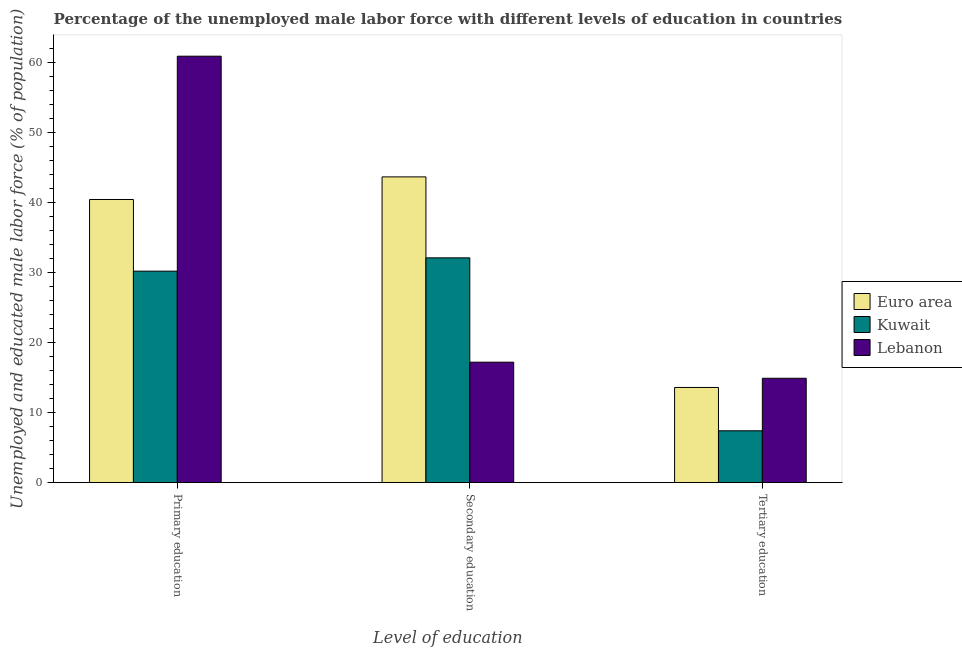How many different coloured bars are there?
Make the answer very short. 3. How many groups of bars are there?
Your answer should be very brief. 3. Are the number of bars on each tick of the X-axis equal?
Provide a short and direct response. Yes. How many bars are there on the 2nd tick from the left?
Provide a succinct answer. 3. What is the label of the 2nd group of bars from the left?
Your response must be concise. Secondary education. What is the percentage of male labor force who received secondary education in Euro area?
Provide a succinct answer. 43.66. Across all countries, what is the maximum percentage of male labor force who received tertiary education?
Provide a short and direct response. 14.9. Across all countries, what is the minimum percentage of male labor force who received primary education?
Offer a terse response. 30.2. In which country was the percentage of male labor force who received primary education maximum?
Ensure brevity in your answer.  Lebanon. In which country was the percentage of male labor force who received secondary education minimum?
Your answer should be very brief. Lebanon. What is the total percentage of male labor force who received secondary education in the graph?
Provide a succinct answer. 92.96. What is the difference between the percentage of male labor force who received tertiary education in Euro area and that in Kuwait?
Offer a terse response. 6.19. What is the difference between the percentage of male labor force who received tertiary education in Euro area and the percentage of male labor force who received primary education in Lebanon?
Provide a succinct answer. -47.31. What is the average percentage of male labor force who received tertiary education per country?
Make the answer very short. 11.96. What is the difference between the percentage of male labor force who received secondary education and percentage of male labor force who received primary education in Lebanon?
Your answer should be compact. -43.7. In how many countries, is the percentage of male labor force who received primary education greater than 26 %?
Offer a terse response. 3. What is the ratio of the percentage of male labor force who received primary education in Kuwait to that in Lebanon?
Provide a short and direct response. 0.5. Is the percentage of male labor force who received primary education in Lebanon less than that in Euro area?
Offer a very short reply. No. What is the difference between the highest and the second highest percentage of male labor force who received primary education?
Give a very brief answer. 20.47. What is the difference between the highest and the lowest percentage of male labor force who received tertiary education?
Provide a succinct answer. 7.5. In how many countries, is the percentage of male labor force who received primary education greater than the average percentage of male labor force who received primary education taken over all countries?
Offer a very short reply. 1. What does the 3rd bar from the left in Tertiary education represents?
Offer a very short reply. Lebanon. What does the 2nd bar from the right in Primary education represents?
Ensure brevity in your answer.  Kuwait. How many bars are there?
Keep it short and to the point. 9. Are all the bars in the graph horizontal?
Provide a short and direct response. No. How many countries are there in the graph?
Your response must be concise. 3. What is the difference between two consecutive major ticks on the Y-axis?
Provide a short and direct response. 10. Are the values on the major ticks of Y-axis written in scientific E-notation?
Your response must be concise. No. Where does the legend appear in the graph?
Give a very brief answer. Center right. What is the title of the graph?
Your answer should be compact. Percentage of the unemployed male labor force with different levels of education in countries. Does "Egypt, Arab Rep." appear as one of the legend labels in the graph?
Keep it short and to the point. No. What is the label or title of the X-axis?
Provide a short and direct response. Level of education. What is the label or title of the Y-axis?
Your answer should be compact. Unemployed and educated male labor force (% of population). What is the Unemployed and educated male labor force (% of population) in Euro area in Primary education?
Offer a very short reply. 40.43. What is the Unemployed and educated male labor force (% of population) of Kuwait in Primary education?
Ensure brevity in your answer.  30.2. What is the Unemployed and educated male labor force (% of population) of Lebanon in Primary education?
Your response must be concise. 60.9. What is the Unemployed and educated male labor force (% of population) in Euro area in Secondary education?
Make the answer very short. 43.66. What is the Unemployed and educated male labor force (% of population) of Kuwait in Secondary education?
Ensure brevity in your answer.  32.1. What is the Unemployed and educated male labor force (% of population) of Lebanon in Secondary education?
Provide a short and direct response. 17.2. What is the Unemployed and educated male labor force (% of population) of Euro area in Tertiary education?
Your response must be concise. 13.59. What is the Unemployed and educated male labor force (% of population) in Kuwait in Tertiary education?
Offer a very short reply. 7.4. What is the Unemployed and educated male labor force (% of population) in Lebanon in Tertiary education?
Offer a terse response. 14.9. Across all Level of education, what is the maximum Unemployed and educated male labor force (% of population) in Euro area?
Your answer should be very brief. 43.66. Across all Level of education, what is the maximum Unemployed and educated male labor force (% of population) in Kuwait?
Offer a very short reply. 32.1. Across all Level of education, what is the maximum Unemployed and educated male labor force (% of population) in Lebanon?
Keep it short and to the point. 60.9. Across all Level of education, what is the minimum Unemployed and educated male labor force (% of population) of Euro area?
Ensure brevity in your answer.  13.59. Across all Level of education, what is the minimum Unemployed and educated male labor force (% of population) in Kuwait?
Offer a terse response. 7.4. Across all Level of education, what is the minimum Unemployed and educated male labor force (% of population) in Lebanon?
Ensure brevity in your answer.  14.9. What is the total Unemployed and educated male labor force (% of population) of Euro area in the graph?
Keep it short and to the point. 97.69. What is the total Unemployed and educated male labor force (% of population) in Kuwait in the graph?
Give a very brief answer. 69.7. What is the total Unemployed and educated male labor force (% of population) in Lebanon in the graph?
Give a very brief answer. 93. What is the difference between the Unemployed and educated male labor force (% of population) in Euro area in Primary education and that in Secondary education?
Offer a terse response. -3.23. What is the difference between the Unemployed and educated male labor force (% of population) in Lebanon in Primary education and that in Secondary education?
Provide a short and direct response. 43.7. What is the difference between the Unemployed and educated male labor force (% of population) of Euro area in Primary education and that in Tertiary education?
Ensure brevity in your answer.  26.84. What is the difference between the Unemployed and educated male labor force (% of population) in Kuwait in Primary education and that in Tertiary education?
Give a very brief answer. 22.8. What is the difference between the Unemployed and educated male labor force (% of population) in Lebanon in Primary education and that in Tertiary education?
Your answer should be compact. 46. What is the difference between the Unemployed and educated male labor force (% of population) of Euro area in Secondary education and that in Tertiary education?
Your answer should be compact. 30.07. What is the difference between the Unemployed and educated male labor force (% of population) of Kuwait in Secondary education and that in Tertiary education?
Your response must be concise. 24.7. What is the difference between the Unemployed and educated male labor force (% of population) in Euro area in Primary education and the Unemployed and educated male labor force (% of population) in Kuwait in Secondary education?
Provide a short and direct response. 8.33. What is the difference between the Unemployed and educated male labor force (% of population) in Euro area in Primary education and the Unemployed and educated male labor force (% of population) in Lebanon in Secondary education?
Keep it short and to the point. 23.23. What is the difference between the Unemployed and educated male labor force (% of population) of Euro area in Primary education and the Unemployed and educated male labor force (% of population) of Kuwait in Tertiary education?
Make the answer very short. 33.03. What is the difference between the Unemployed and educated male labor force (% of population) in Euro area in Primary education and the Unemployed and educated male labor force (% of population) in Lebanon in Tertiary education?
Make the answer very short. 25.53. What is the difference between the Unemployed and educated male labor force (% of population) in Euro area in Secondary education and the Unemployed and educated male labor force (% of population) in Kuwait in Tertiary education?
Offer a terse response. 36.26. What is the difference between the Unemployed and educated male labor force (% of population) of Euro area in Secondary education and the Unemployed and educated male labor force (% of population) of Lebanon in Tertiary education?
Offer a terse response. 28.76. What is the difference between the Unemployed and educated male labor force (% of population) in Kuwait in Secondary education and the Unemployed and educated male labor force (% of population) in Lebanon in Tertiary education?
Your answer should be very brief. 17.2. What is the average Unemployed and educated male labor force (% of population) in Euro area per Level of education?
Offer a very short reply. 32.56. What is the average Unemployed and educated male labor force (% of population) of Kuwait per Level of education?
Provide a short and direct response. 23.23. What is the difference between the Unemployed and educated male labor force (% of population) in Euro area and Unemployed and educated male labor force (% of population) in Kuwait in Primary education?
Provide a short and direct response. 10.23. What is the difference between the Unemployed and educated male labor force (% of population) in Euro area and Unemployed and educated male labor force (% of population) in Lebanon in Primary education?
Offer a very short reply. -20.47. What is the difference between the Unemployed and educated male labor force (% of population) of Kuwait and Unemployed and educated male labor force (% of population) of Lebanon in Primary education?
Offer a very short reply. -30.7. What is the difference between the Unemployed and educated male labor force (% of population) of Euro area and Unemployed and educated male labor force (% of population) of Kuwait in Secondary education?
Make the answer very short. 11.56. What is the difference between the Unemployed and educated male labor force (% of population) in Euro area and Unemployed and educated male labor force (% of population) in Lebanon in Secondary education?
Provide a short and direct response. 26.46. What is the difference between the Unemployed and educated male labor force (% of population) in Euro area and Unemployed and educated male labor force (% of population) in Kuwait in Tertiary education?
Ensure brevity in your answer.  6.19. What is the difference between the Unemployed and educated male labor force (% of population) in Euro area and Unemployed and educated male labor force (% of population) in Lebanon in Tertiary education?
Offer a very short reply. -1.31. What is the difference between the Unemployed and educated male labor force (% of population) in Kuwait and Unemployed and educated male labor force (% of population) in Lebanon in Tertiary education?
Provide a succinct answer. -7.5. What is the ratio of the Unemployed and educated male labor force (% of population) in Euro area in Primary education to that in Secondary education?
Keep it short and to the point. 0.93. What is the ratio of the Unemployed and educated male labor force (% of population) of Kuwait in Primary education to that in Secondary education?
Keep it short and to the point. 0.94. What is the ratio of the Unemployed and educated male labor force (% of population) in Lebanon in Primary education to that in Secondary education?
Offer a terse response. 3.54. What is the ratio of the Unemployed and educated male labor force (% of population) of Euro area in Primary education to that in Tertiary education?
Make the answer very short. 2.98. What is the ratio of the Unemployed and educated male labor force (% of population) in Kuwait in Primary education to that in Tertiary education?
Your answer should be compact. 4.08. What is the ratio of the Unemployed and educated male labor force (% of population) of Lebanon in Primary education to that in Tertiary education?
Keep it short and to the point. 4.09. What is the ratio of the Unemployed and educated male labor force (% of population) in Euro area in Secondary education to that in Tertiary education?
Your response must be concise. 3.21. What is the ratio of the Unemployed and educated male labor force (% of population) in Kuwait in Secondary education to that in Tertiary education?
Provide a succinct answer. 4.34. What is the ratio of the Unemployed and educated male labor force (% of population) in Lebanon in Secondary education to that in Tertiary education?
Provide a succinct answer. 1.15. What is the difference between the highest and the second highest Unemployed and educated male labor force (% of population) in Euro area?
Ensure brevity in your answer.  3.23. What is the difference between the highest and the second highest Unemployed and educated male labor force (% of population) of Lebanon?
Your answer should be very brief. 43.7. What is the difference between the highest and the lowest Unemployed and educated male labor force (% of population) of Euro area?
Your answer should be compact. 30.07. What is the difference between the highest and the lowest Unemployed and educated male labor force (% of population) of Kuwait?
Give a very brief answer. 24.7. 